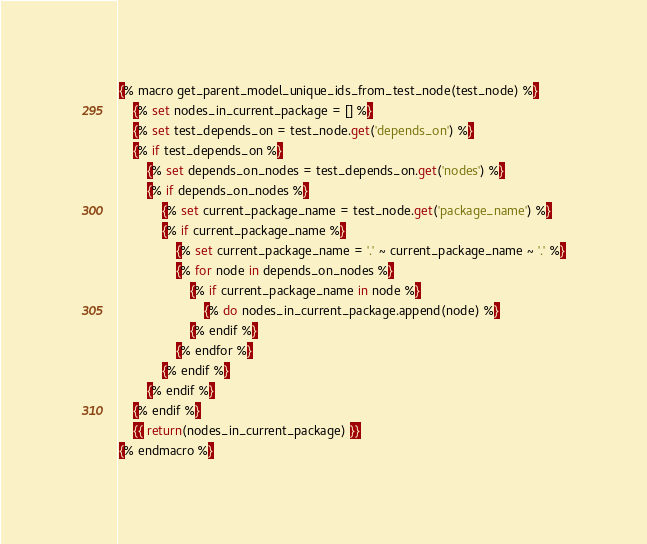Convert code to text. <code><loc_0><loc_0><loc_500><loc_500><_SQL_>{% macro get_parent_model_unique_ids_from_test_node(test_node) %}
    {% set nodes_in_current_package = [] %}
    {% set test_depends_on = test_node.get('depends_on') %}
    {% if test_depends_on %}
        {% set depends_on_nodes = test_depends_on.get('nodes') %}
        {% if depends_on_nodes %}
            {% set current_package_name = test_node.get('package_name') %}
            {% if current_package_name %}
                {% set current_package_name = '.' ~ current_package_name ~ '.' %}
                {% for node in depends_on_nodes %}
                    {% if current_package_name in node %}
                        {% do nodes_in_current_package.append(node) %}
                    {% endif %}
                {% endfor %}
            {% endif %}
        {% endif %}
    {% endif %}
    {{ return(nodes_in_current_package) }}
{% endmacro %}
</code> 